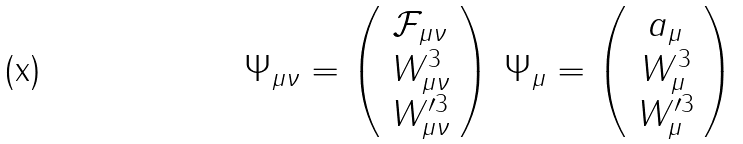<formula> <loc_0><loc_0><loc_500><loc_500>\Psi _ { \mu \nu } = \left ( \begin{array} { c } \mathcal { F } _ { \mu \nu } \\ W ^ { 3 } _ { \mu \nu } \\ W ^ { \prime 3 } _ { \mu \nu } \end{array} \right ) \, \Psi _ { \mu } = \left ( \begin{array} { c } a _ { \mu } \\ W ^ { 3 } _ { \mu } \\ W ^ { \prime 3 } _ { \mu } \end{array} \right )</formula> 